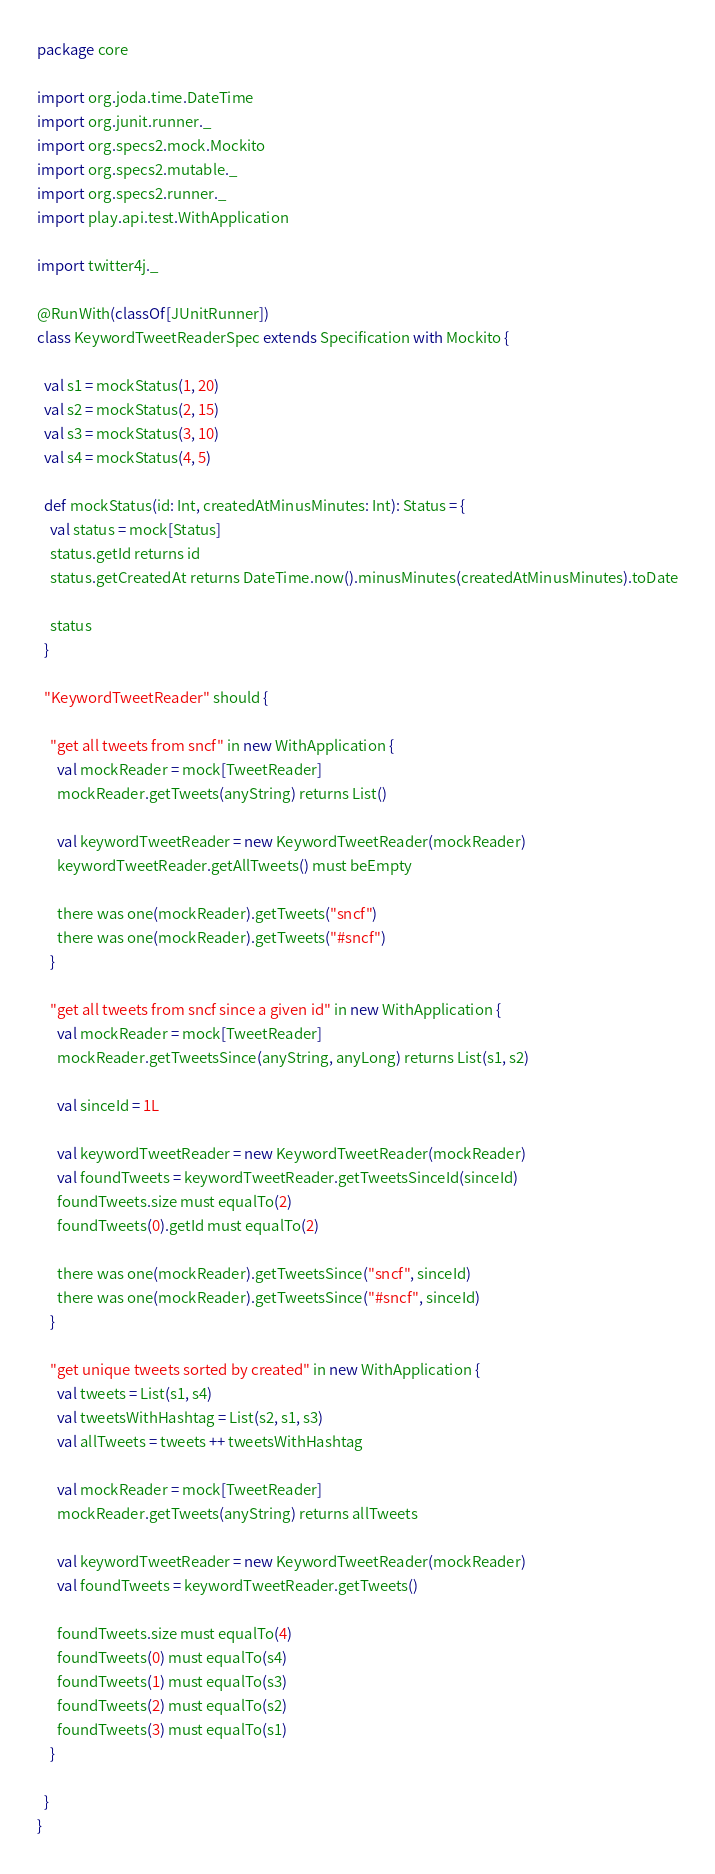<code> <loc_0><loc_0><loc_500><loc_500><_Scala_>package core

import org.joda.time.DateTime
import org.junit.runner._
import org.specs2.mock.Mockito
import org.specs2.mutable._
import org.specs2.runner._
import play.api.test.WithApplication

import twitter4j._

@RunWith(classOf[JUnitRunner])
class KeywordTweetReaderSpec extends Specification with Mockito {

  val s1 = mockStatus(1, 20)
  val s2 = mockStatus(2, 15)
  val s3 = mockStatus(3, 10)
  val s4 = mockStatus(4, 5)

  def mockStatus(id: Int, createdAtMinusMinutes: Int): Status = {
    val status = mock[Status]
    status.getId returns id
    status.getCreatedAt returns DateTime.now().minusMinutes(createdAtMinusMinutes).toDate

    status
  }

  "KeywordTweetReader" should {

    "get all tweets from sncf" in new WithApplication {
      val mockReader = mock[TweetReader]
      mockReader.getTweets(anyString) returns List()

      val keywordTweetReader = new KeywordTweetReader(mockReader)
      keywordTweetReader.getAllTweets() must beEmpty

      there was one(mockReader).getTweets("sncf")
      there was one(mockReader).getTweets("#sncf")
    }

    "get all tweets from sncf since a given id" in new WithApplication {
      val mockReader = mock[TweetReader]
      mockReader.getTweetsSince(anyString, anyLong) returns List(s1, s2)

      val sinceId = 1L

      val keywordTweetReader = new KeywordTweetReader(mockReader)
      val foundTweets = keywordTweetReader.getTweetsSinceId(sinceId)
      foundTweets.size must equalTo(2)
      foundTweets(0).getId must equalTo(2)

      there was one(mockReader).getTweetsSince("sncf", sinceId)
      there was one(mockReader).getTweetsSince("#sncf", sinceId)
    }

    "get unique tweets sorted by created" in new WithApplication {
      val tweets = List(s1, s4)
      val tweetsWithHashtag = List(s2, s1, s3)
      val allTweets = tweets ++ tweetsWithHashtag

      val mockReader = mock[TweetReader]
      mockReader.getTweets(anyString) returns allTweets

      val keywordTweetReader = new KeywordTweetReader(mockReader)
      val foundTweets = keywordTweetReader.getTweets()

      foundTweets.size must equalTo(4)
      foundTweets(0) must equalTo(s4)
      foundTweets(1) must equalTo(s3)
      foundTweets(2) must equalTo(s2)
      foundTweets(3) must equalTo(s1)
    }

  }
}
</code> 